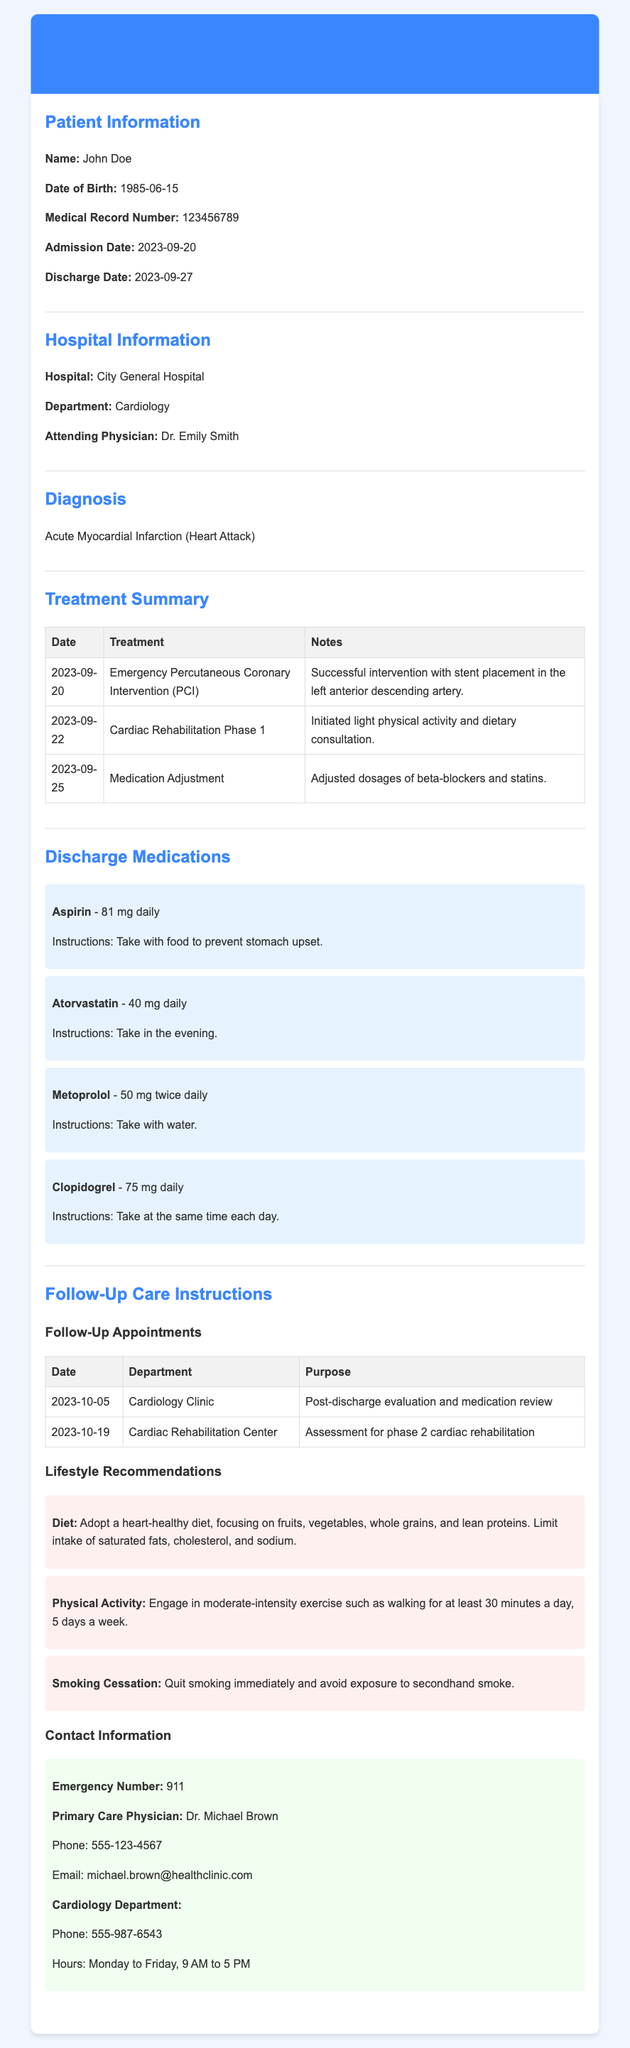What is the patient's name? The patient's name is displayed in the Patient Information section of the document.
Answer: John Doe What is the discharge date? The discharge date is noted under the Patient Information section of the document.
Answer: 2023-09-27 Who is the attending physician? The attending physician's name can be found in the Hospital Information section.
Answer: Dr. Emily Smith What diagnosis was given? The diagnosis can be found in the Diagnosis section of the document.
Answer: Acute Myocardial Infarction How many follow-up appointments are listed? The number of follow-up appointments is found in the Follow-Up Care Instructions section under the Follow-Up Appointments table.
Answer: 2 What lifestyle recommendation is given regarding diet? The lifestyle recommendations include dietary guidance, which is summarized in the Lifestyle Recommendations section.
Answer: Adopt a heart-healthy diet When is the next follow-up appointment? The date of the next follow-up appointment is shown in the Follow-Up Appointments table.
Answer: 2023-10-05 What medication should be taken in the evening? The medication with specific timing instructions can be found in the Discharge Medications section.
Answer: Atorvastatin What is the emergency number provided? The emergency number is stated in the Contact Information section of the document.
Answer: 911 